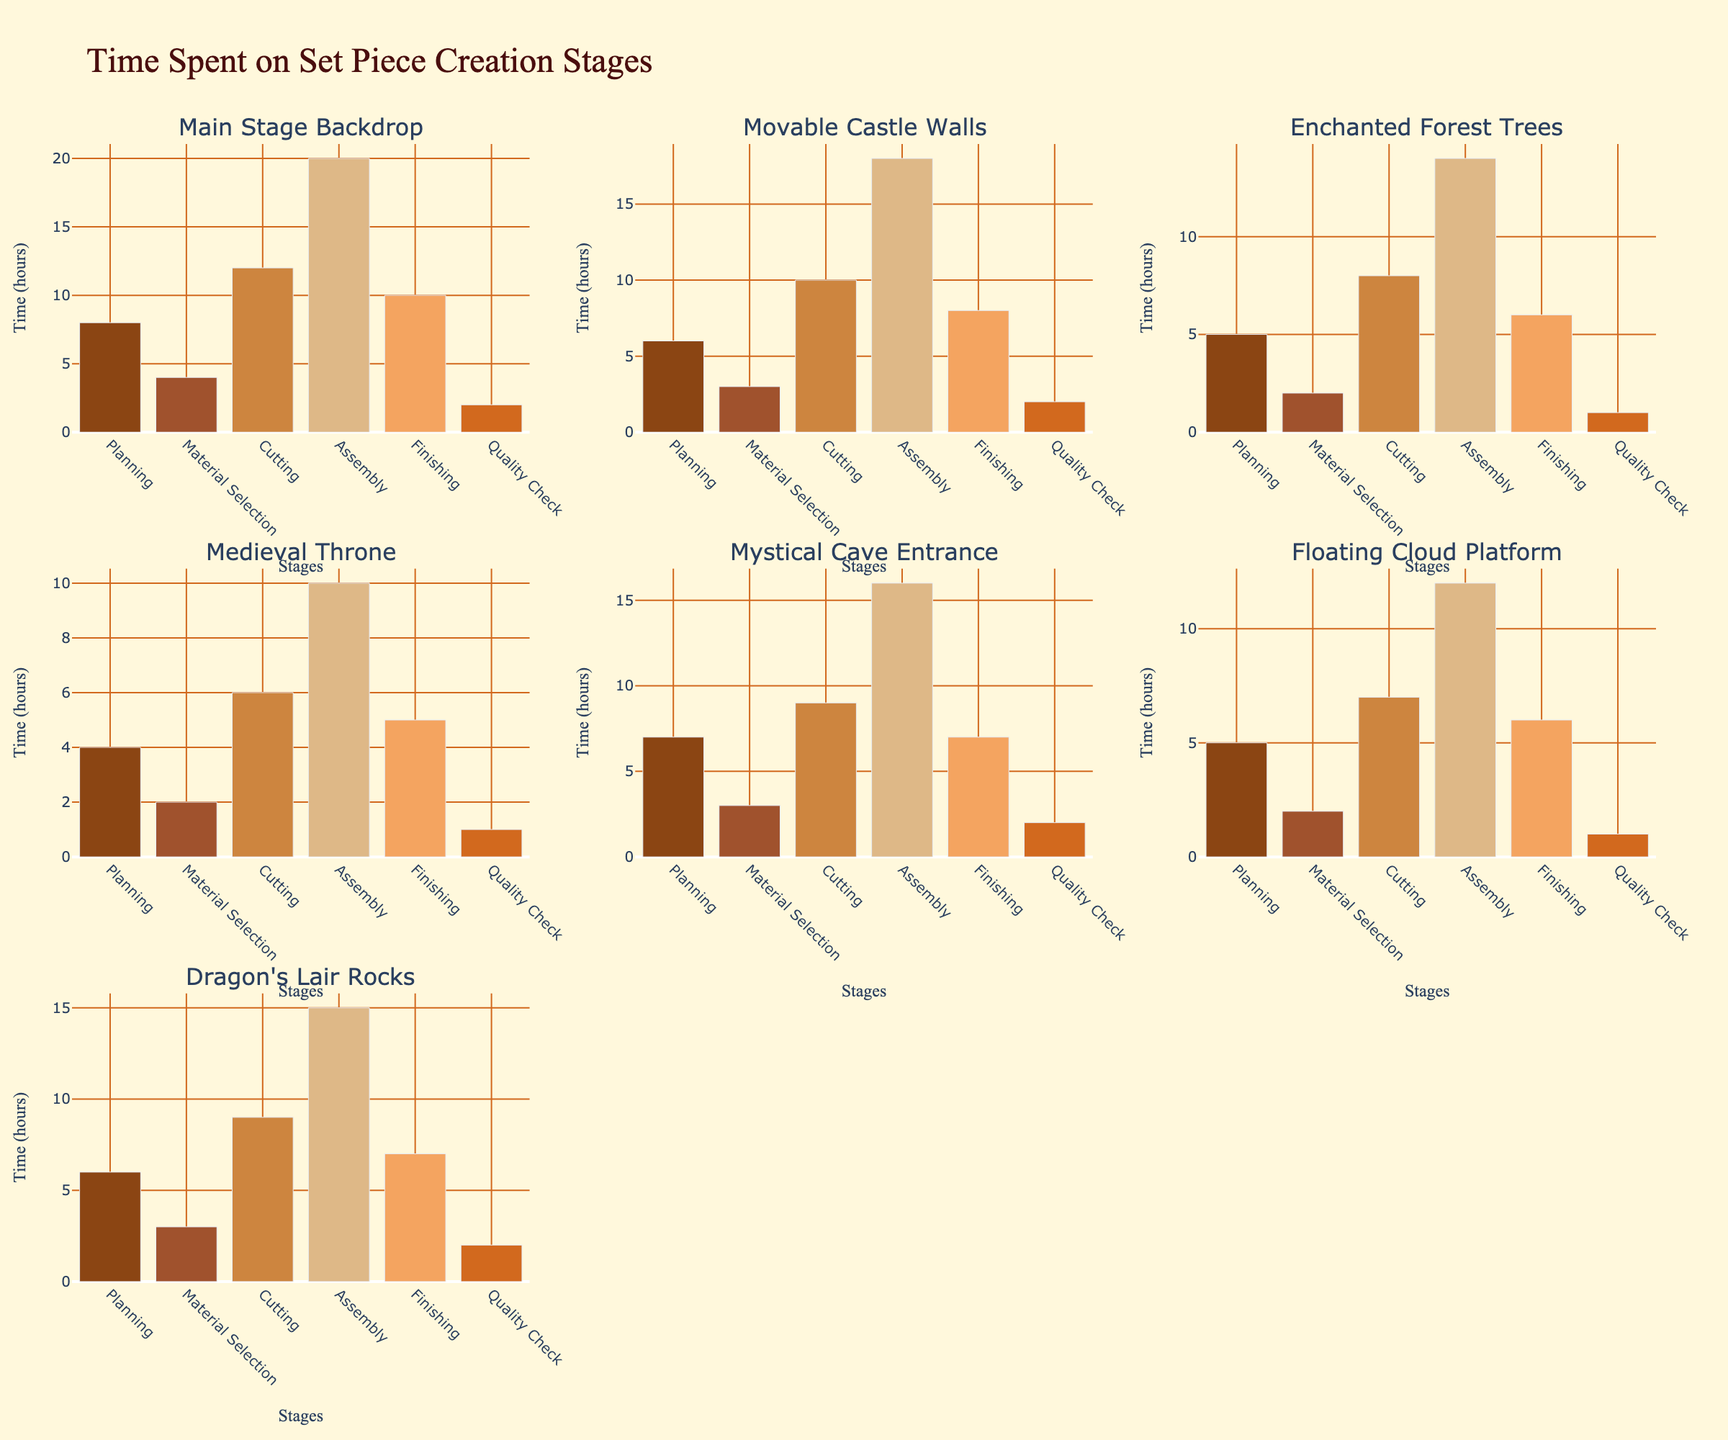what are the highest and lowest voter turnout percentages across all age groups for the 2023 election? The scatterplot matrix shows data points labeled with age group and their voter turnout percentages. Check the voter turnout percentages for the 2023 election column. The highest turnout is for the age group 65-74 at 80.1%, and the lowest is for the age group 18-24 at 38.2%.
Answer: Highest: 80.1%, Lowest: 38.2% Do older age groups have a consistently higher voter turnout than younger age groups in each election year? By examining the scatter plot matrix, we can see the voter turnout percentages for all election years (2015, 2019, and 2023) across different age groups. Older age groups such as 55-64 and 65-74 show consistently higher voter turnout percentages than younger groups like 18-24 and 25-34 in every election year.
Answer: Yes For any given election year, which two age groups have the closest voter turnout percentages? Looking at the scatter plot matrix, observe the data points for each election year. In 2023, age groups 55-64 and 65-74 have voter turnout percentages of 73.8% and 80.1%. The difference is more significant than between 75+ and 65-74, which have turnouts of 70.8% and 80.1%. For more precision, we need to ensure other years too. Examine each pair closely in 2015 and 2019 as well, to conclude for 2023 final pairy groups with minimal difference.
Answer: Sometimes it's 55-64 and 65-74 What trend can be seen from election year to election year for the youngest age group, 18-24? Observing the scatter plot matrix, look at the points labeled '18-24' for each election year. In 2015, the turnout is 32.5%, it increases to 35.8% in 2019, and then rises again to 38.2% in 2023. The trend is an increasing voter turnout percentage for the youngest age group across the three election years.
Answer: Increasing trend In the 2019 election, which age group had the most significant increase in voter turnout compared to the 2015 election? From the scatter plot matrix, look at the voter turnout percentages for each age group in both 2015 and 2019. Calculate the difference: for 18-24, it increases by 3.3%, for 25-34 by 2.4%, for 35-44 by 1.6%, and so on. The age group 18-24 shows the most significant increase of 3.3%.
Answer: Age group 18-24 